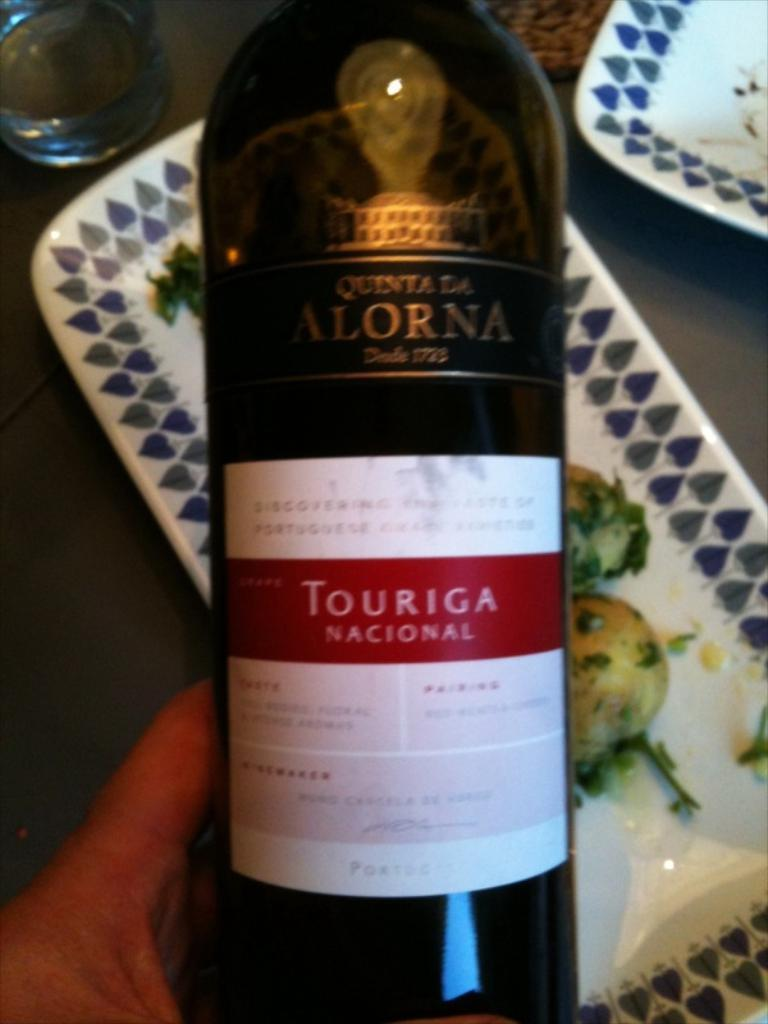<image>
Share a concise interpretation of the image provided. The black bottle with gold lettering and a white label with red lettering says Touriga  Nacional. 